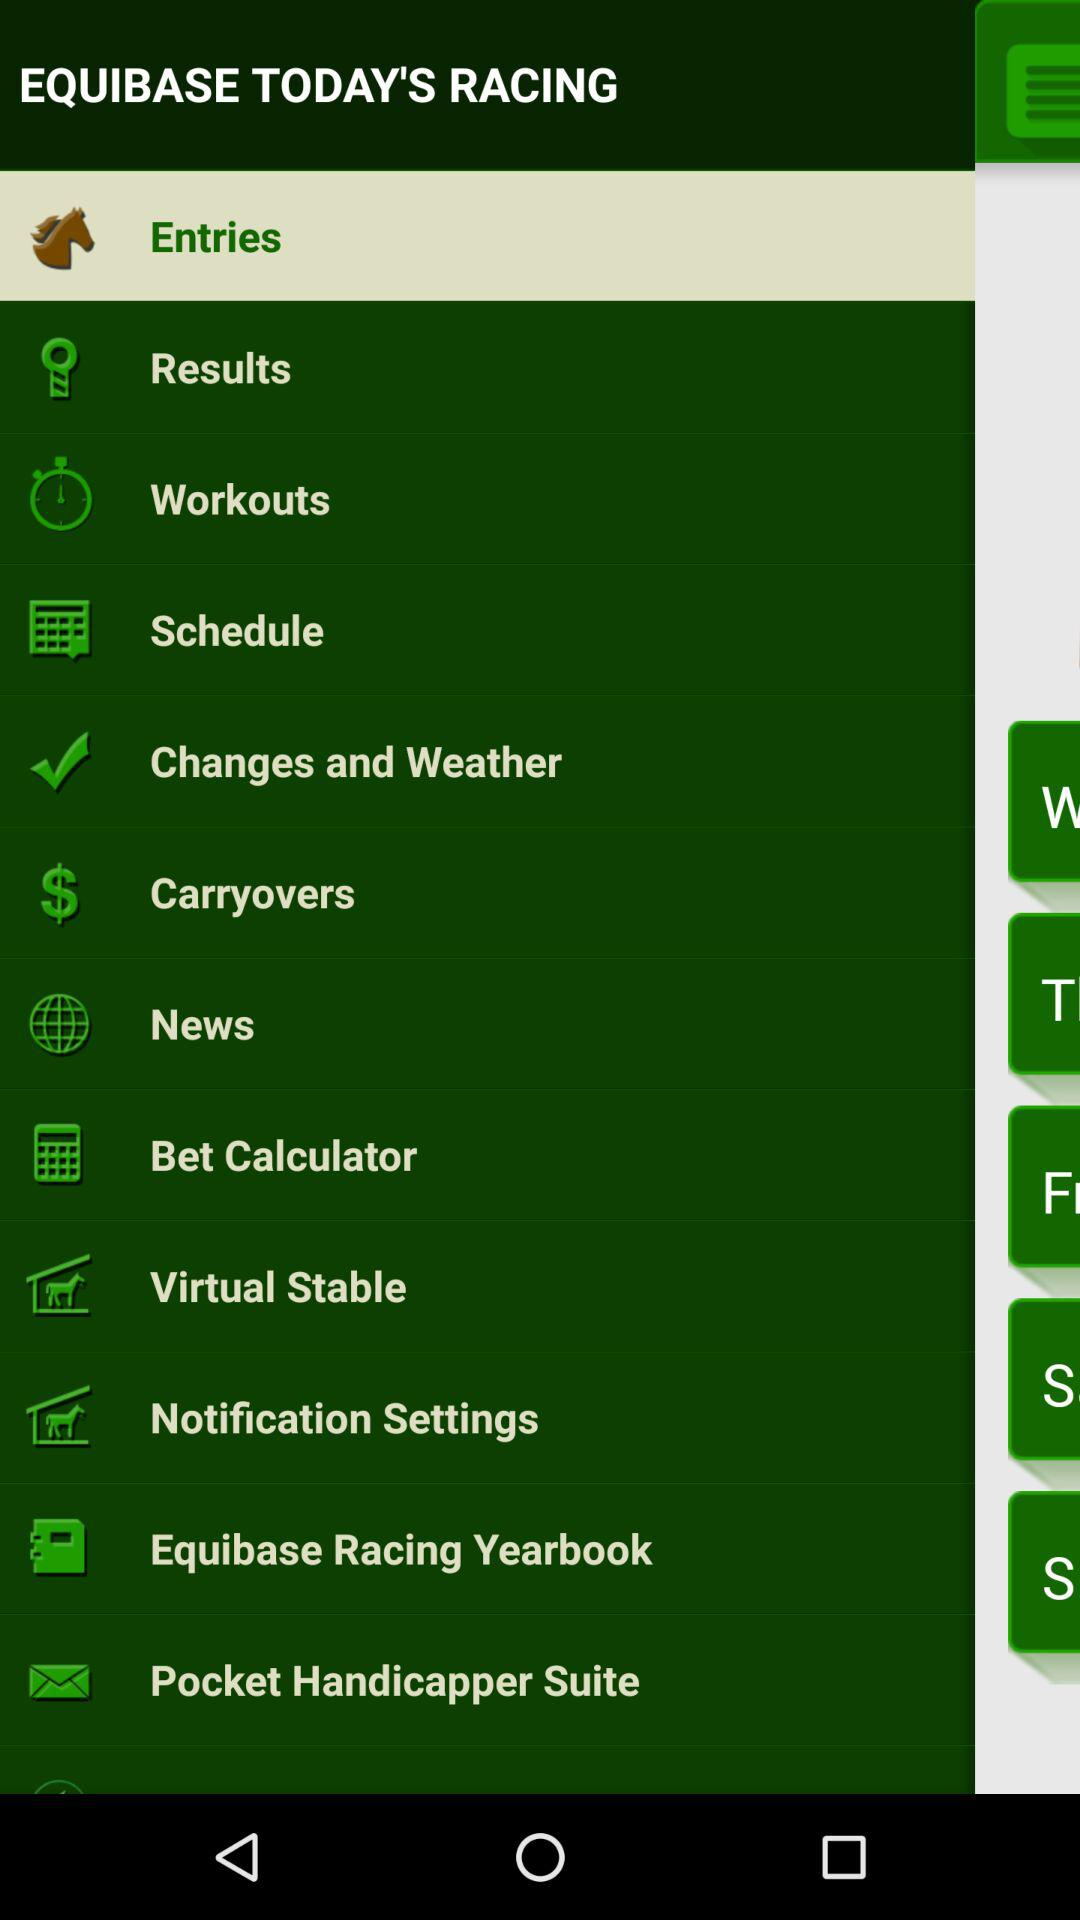What is the app name? The app name is "EQUIBASE TODAY'S RACING". 